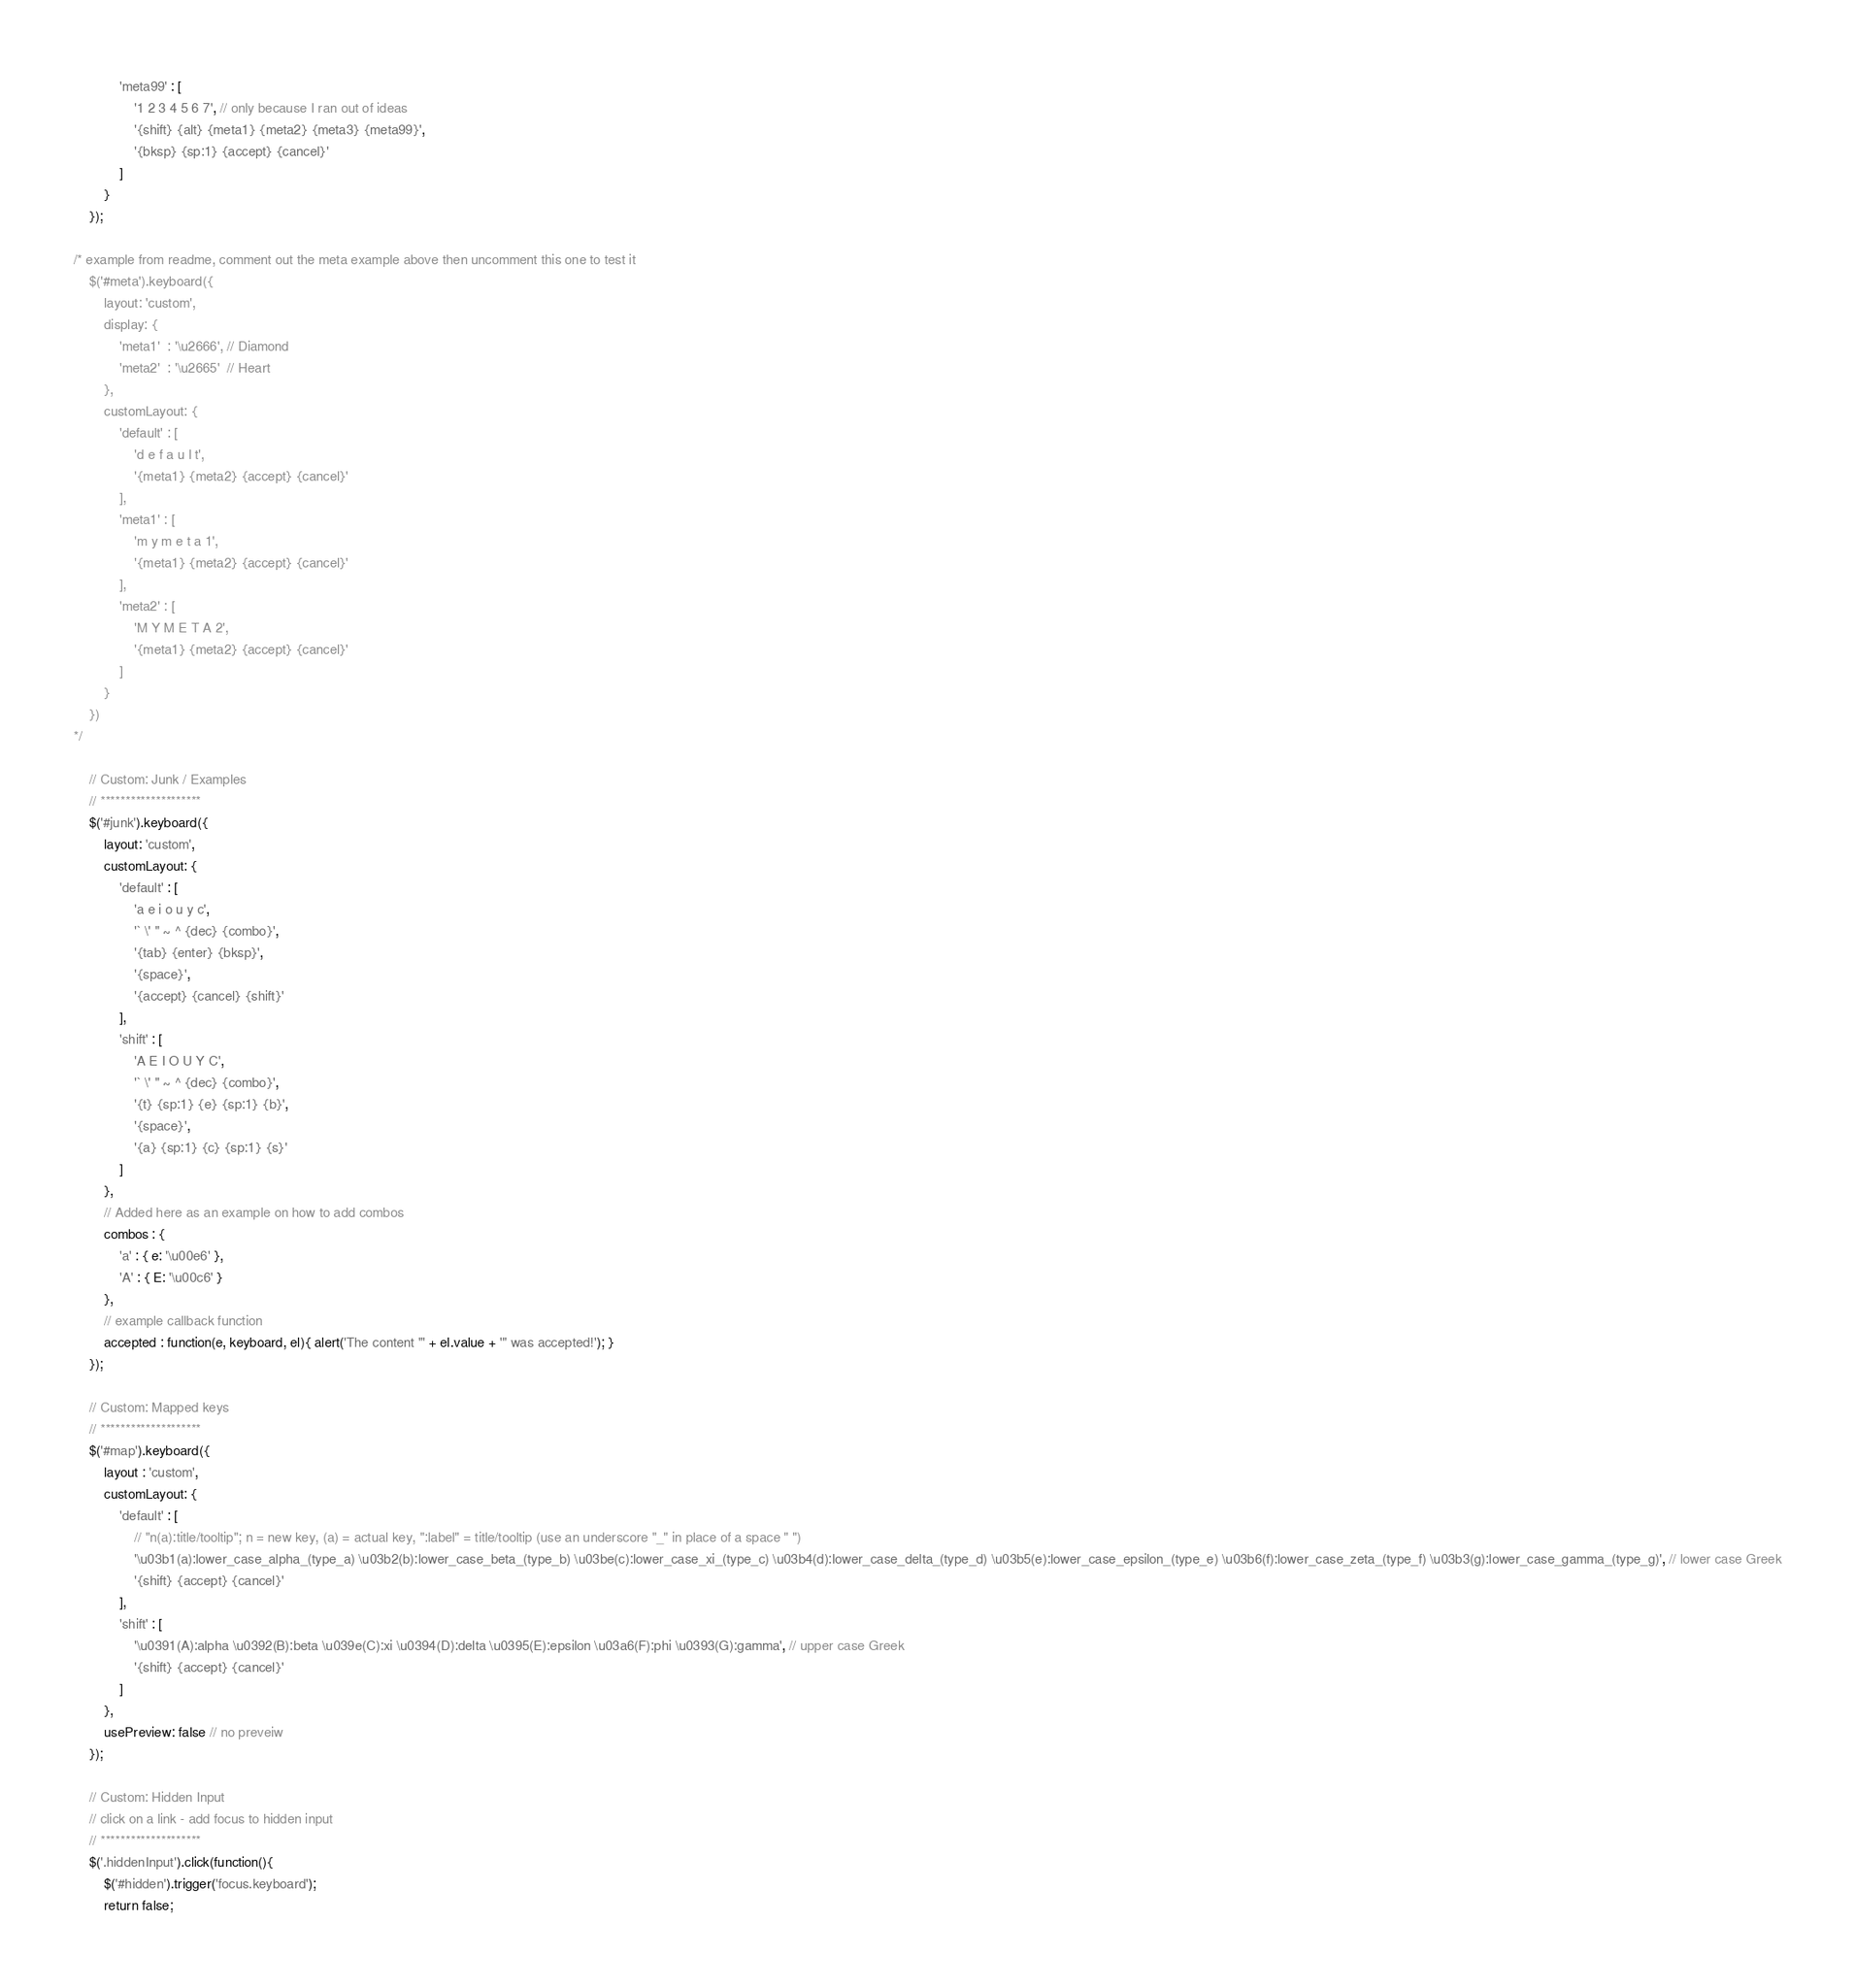Convert code to text. <code><loc_0><loc_0><loc_500><loc_500><_JavaScript_>			'meta99' : [
				'1 2 3 4 5 6 7', // only because I ran out of ideas
				'{shift} {alt} {meta1} {meta2} {meta3} {meta99}',
				'{bksp} {sp:1} {accept} {cancel}'
			]
		}
	});

/* example from readme, comment out the meta example above then uncomment this one to test it
	$('#meta').keyboard({
		layout: 'custom',
		display: {
			'meta1'  : '\u2666', // Diamond
			'meta2'  : '\u2665'  // Heart
		},
		customLayout: {
			'default' : [
				'd e f a u l t',
				'{meta1} {meta2} {accept} {cancel}'
			],
			'meta1' : [
				'm y m e t a 1',
				'{meta1} {meta2} {accept} {cancel}'
			],
			'meta2' : [
				'M Y M E T A 2',
				'{meta1} {meta2} {accept} {cancel}'
			]
		}
	})
*/

	// Custom: Junk / Examples
	// ********************
	$('#junk').keyboard({
		layout: 'custom',
		customLayout: {
			'default' : [
				'a e i o u y c',
				'` \' " ~ ^ {dec} {combo}',
				'{tab} {enter} {bksp}',
				'{space}',
				'{accept} {cancel} {shift}'
			],
			'shift' : [
				'A E I O U Y C',
				'` \' " ~ ^ {dec} {combo}',
				'{t} {sp:1} {e} {sp:1} {b}',
				'{space}',
				'{a} {sp:1} {c} {sp:1} {s}'
			]
		},
		// Added here as an example on how to add combos
		combos : {
			'a' : { e: '\u00e6' },
			'A' : { E: '\u00c6' }
		},
		// example callback function
		accepted : function(e, keyboard, el){ alert('The content "' + el.value + '" was accepted!'); }
	});

	// Custom: Mapped keys
	// ********************
	$('#map').keyboard({
		layout : 'custom',
		customLayout: {
			'default' : [ 
				// "n(a):title/tooltip"; n = new key, (a) = actual key, ":label" = title/tooltip (use an underscore "_" in place of a space " ")
				'\u03b1(a):lower_case_alpha_(type_a) \u03b2(b):lower_case_beta_(type_b) \u03be(c):lower_case_xi_(type_c) \u03b4(d):lower_case_delta_(type_d) \u03b5(e):lower_case_epsilon_(type_e) \u03b6(f):lower_case_zeta_(type_f) \u03b3(g):lower_case_gamma_(type_g)', // lower case Greek
				'{shift} {accept} {cancel}'
			],
			'shift' : [
				'\u0391(A):alpha \u0392(B):beta \u039e(C):xi \u0394(D):delta \u0395(E):epsilon \u03a6(F):phi \u0393(G):gamma', // upper case Greek
				'{shift} {accept} {cancel}'
			]
		},
		usePreview: false // no preveiw
	});

	// Custom: Hidden Input
	// click on a link - add focus to hidden input
	// ********************
	$('.hiddenInput').click(function(){
		$('#hidden').trigger('focus.keyboard');
		return false;</code> 